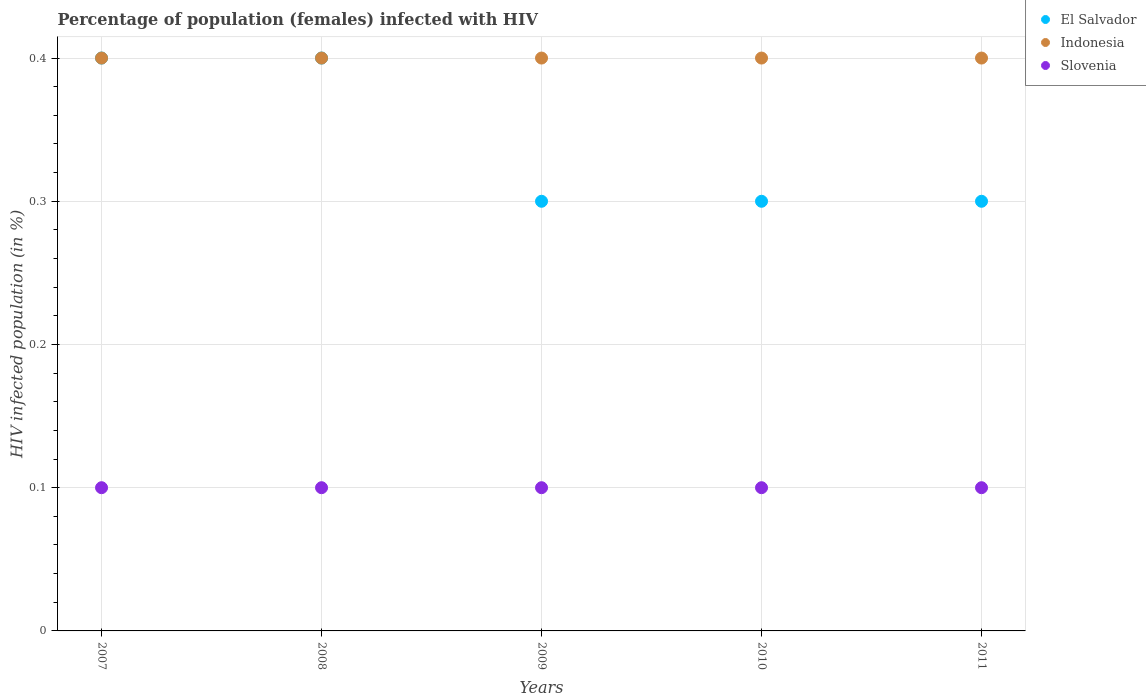What is the percentage of HIV infected female population in El Salvador in 2007?
Keep it short and to the point. 0.4. In which year was the percentage of HIV infected female population in Slovenia maximum?
Your response must be concise. 2007. In which year was the percentage of HIV infected female population in El Salvador minimum?
Your answer should be compact. 2009. What is the difference between the percentage of HIV infected female population in El Salvador in 2007 and that in 2009?
Your answer should be very brief. 0.1. What is the average percentage of HIV infected female population in Indonesia per year?
Provide a succinct answer. 0.4. In the year 2010, what is the difference between the percentage of HIV infected female population in El Salvador and percentage of HIV infected female population in Slovenia?
Provide a succinct answer. 0.2. In how many years, is the percentage of HIV infected female population in Indonesia greater than 0.26 %?
Your answer should be very brief. 5. What is the ratio of the percentage of HIV infected female population in Indonesia in 2009 to that in 2010?
Ensure brevity in your answer.  1. Is the difference between the percentage of HIV infected female population in El Salvador in 2008 and 2010 greater than the difference between the percentage of HIV infected female population in Slovenia in 2008 and 2010?
Provide a succinct answer. Yes. What is the difference between the highest and the second highest percentage of HIV infected female population in El Salvador?
Your answer should be very brief. 0. What is the difference between the highest and the lowest percentage of HIV infected female population in Indonesia?
Provide a short and direct response. 0. Does the percentage of HIV infected female population in Slovenia monotonically increase over the years?
Ensure brevity in your answer.  No. Is the percentage of HIV infected female population in Indonesia strictly less than the percentage of HIV infected female population in Slovenia over the years?
Offer a terse response. No. How many years are there in the graph?
Make the answer very short. 5. What is the difference between two consecutive major ticks on the Y-axis?
Provide a short and direct response. 0.1. Does the graph contain grids?
Your answer should be compact. Yes. Where does the legend appear in the graph?
Offer a very short reply. Top right. How many legend labels are there?
Your response must be concise. 3. What is the title of the graph?
Keep it short and to the point. Percentage of population (females) infected with HIV. Does "Sub-Saharan Africa (all income levels)" appear as one of the legend labels in the graph?
Offer a terse response. No. What is the label or title of the Y-axis?
Provide a short and direct response. HIV infected population (in %). What is the HIV infected population (in %) of Indonesia in 2007?
Provide a short and direct response. 0.4. What is the HIV infected population (in %) of Indonesia in 2008?
Offer a very short reply. 0.4. What is the HIV infected population (in %) of Slovenia in 2008?
Provide a short and direct response. 0.1. What is the HIV infected population (in %) in Indonesia in 2009?
Your answer should be compact. 0.4. What is the HIV infected population (in %) of Slovenia in 2009?
Give a very brief answer. 0.1. What is the HIV infected population (in %) in Slovenia in 2011?
Offer a terse response. 0.1. Across all years, what is the maximum HIV infected population (in %) of Indonesia?
Ensure brevity in your answer.  0.4. Across all years, what is the maximum HIV infected population (in %) in Slovenia?
Offer a terse response. 0.1. Across all years, what is the minimum HIV infected population (in %) in El Salvador?
Offer a terse response. 0.3. What is the total HIV infected population (in %) of Indonesia in the graph?
Your response must be concise. 2. What is the total HIV infected population (in %) of Slovenia in the graph?
Give a very brief answer. 0.5. What is the difference between the HIV infected population (in %) in Slovenia in 2007 and that in 2008?
Your answer should be very brief. 0. What is the difference between the HIV infected population (in %) in Slovenia in 2007 and that in 2009?
Make the answer very short. 0. What is the difference between the HIV infected population (in %) in El Salvador in 2007 and that in 2010?
Keep it short and to the point. 0.1. What is the difference between the HIV infected population (in %) in Indonesia in 2007 and that in 2010?
Your answer should be compact. 0. What is the difference between the HIV infected population (in %) of El Salvador in 2007 and that in 2011?
Your answer should be very brief. 0.1. What is the difference between the HIV infected population (in %) in El Salvador in 2008 and that in 2009?
Make the answer very short. 0.1. What is the difference between the HIV infected population (in %) of Indonesia in 2008 and that in 2009?
Keep it short and to the point. 0. What is the difference between the HIV infected population (in %) in El Salvador in 2008 and that in 2010?
Keep it short and to the point. 0.1. What is the difference between the HIV infected population (in %) in Indonesia in 2008 and that in 2011?
Your answer should be compact. 0. What is the difference between the HIV infected population (in %) in Slovenia in 2008 and that in 2011?
Offer a terse response. 0. What is the difference between the HIV infected population (in %) in El Salvador in 2009 and that in 2010?
Ensure brevity in your answer.  0. What is the difference between the HIV infected population (in %) in Slovenia in 2009 and that in 2010?
Provide a succinct answer. 0. What is the difference between the HIV infected population (in %) of Slovenia in 2010 and that in 2011?
Your answer should be compact. 0. What is the difference between the HIV infected population (in %) in El Salvador in 2007 and the HIV infected population (in %) in Indonesia in 2008?
Your response must be concise. 0. What is the difference between the HIV infected population (in %) in Indonesia in 2007 and the HIV infected population (in %) in Slovenia in 2008?
Provide a short and direct response. 0.3. What is the difference between the HIV infected population (in %) of Indonesia in 2007 and the HIV infected population (in %) of Slovenia in 2009?
Offer a terse response. 0.3. What is the difference between the HIV infected population (in %) in El Salvador in 2007 and the HIV infected population (in %) in Slovenia in 2011?
Your response must be concise. 0.3. What is the difference between the HIV infected population (in %) of Indonesia in 2007 and the HIV infected population (in %) of Slovenia in 2011?
Your answer should be compact. 0.3. What is the difference between the HIV infected population (in %) in El Salvador in 2008 and the HIV infected population (in %) in Slovenia in 2009?
Your response must be concise. 0.3. What is the difference between the HIV infected population (in %) in El Salvador in 2008 and the HIV infected population (in %) in Indonesia in 2010?
Your response must be concise. 0. What is the difference between the HIV infected population (in %) of El Salvador in 2008 and the HIV infected population (in %) of Slovenia in 2010?
Make the answer very short. 0.3. What is the difference between the HIV infected population (in %) of El Salvador in 2008 and the HIV infected population (in %) of Slovenia in 2011?
Make the answer very short. 0.3. What is the difference between the HIV infected population (in %) of Indonesia in 2008 and the HIV infected population (in %) of Slovenia in 2011?
Ensure brevity in your answer.  0.3. What is the difference between the HIV infected population (in %) in Indonesia in 2009 and the HIV infected population (in %) in Slovenia in 2010?
Your answer should be very brief. 0.3. What is the difference between the HIV infected population (in %) in El Salvador in 2009 and the HIV infected population (in %) in Indonesia in 2011?
Keep it short and to the point. -0.1. What is the difference between the HIV infected population (in %) in El Salvador in 2009 and the HIV infected population (in %) in Slovenia in 2011?
Provide a succinct answer. 0.2. What is the difference between the HIV infected population (in %) of Indonesia in 2009 and the HIV infected population (in %) of Slovenia in 2011?
Your answer should be very brief. 0.3. What is the difference between the HIV infected population (in %) in El Salvador in 2010 and the HIV infected population (in %) in Indonesia in 2011?
Make the answer very short. -0.1. What is the difference between the HIV infected population (in %) of Indonesia in 2010 and the HIV infected population (in %) of Slovenia in 2011?
Offer a very short reply. 0.3. What is the average HIV infected population (in %) in El Salvador per year?
Provide a succinct answer. 0.34. What is the average HIV infected population (in %) of Indonesia per year?
Your response must be concise. 0.4. In the year 2008, what is the difference between the HIV infected population (in %) in El Salvador and HIV infected population (in %) in Indonesia?
Offer a terse response. 0. In the year 2008, what is the difference between the HIV infected population (in %) in El Salvador and HIV infected population (in %) in Slovenia?
Make the answer very short. 0.3. In the year 2008, what is the difference between the HIV infected population (in %) in Indonesia and HIV infected population (in %) in Slovenia?
Give a very brief answer. 0.3. In the year 2009, what is the difference between the HIV infected population (in %) of El Salvador and HIV infected population (in %) of Indonesia?
Provide a short and direct response. -0.1. In the year 2009, what is the difference between the HIV infected population (in %) in El Salvador and HIV infected population (in %) in Slovenia?
Keep it short and to the point. 0.2. In the year 2009, what is the difference between the HIV infected population (in %) of Indonesia and HIV infected population (in %) of Slovenia?
Provide a succinct answer. 0.3. In the year 2011, what is the difference between the HIV infected population (in %) in El Salvador and HIV infected population (in %) in Slovenia?
Give a very brief answer. 0.2. What is the ratio of the HIV infected population (in %) of El Salvador in 2007 to that in 2008?
Your response must be concise. 1. What is the ratio of the HIV infected population (in %) in El Salvador in 2007 to that in 2009?
Provide a short and direct response. 1.33. What is the ratio of the HIV infected population (in %) in Indonesia in 2007 to that in 2009?
Offer a very short reply. 1. What is the ratio of the HIV infected population (in %) of Slovenia in 2007 to that in 2009?
Offer a terse response. 1. What is the ratio of the HIV infected population (in %) in El Salvador in 2007 to that in 2010?
Your response must be concise. 1.33. What is the ratio of the HIV infected population (in %) in Indonesia in 2007 to that in 2010?
Keep it short and to the point. 1. What is the ratio of the HIV infected population (in %) in Slovenia in 2007 to that in 2010?
Make the answer very short. 1. What is the ratio of the HIV infected population (in %) in El Salvador in 2008 to that in 2010?
Your answer should be very brief. 1.33. What is the ratio of the HIV infected population (in %) of Indonesia in 2008 to that in 2010?
Provide a succinct answer. 1. What is the ratio of the HIV infected population (in %) of Slovenia in 2008 to that in 2010?
Keep it short and to the point. 1. What is the ratio of the HIV infected population (in %) of El Salvador in 2008 to that in 2011?
Give a very brief answer. 1.33. What is the ratio of the HIV infected population (in %) in Slovenia in 2008 to that in 2011?
Your answer should be compact. 1. What is the ratio of the HIV infected population (in %) in El Salvador in 2009 to that in 2010?
Offer a terse response. 1. What is the ratio of the HIV infected population (in %) in Slovenia in 2009 to that in 2011?
Your answer should be compact. 1. What is the ratio of the HIV infected population (in %) in Indonesia in 2010 to that in 2011?
Give a very brief answer. 1. What is the difference between the highest and the second highest HIV infected population (in %) in El Salvador?
Offer a terse response. 0. What is the difference between the highest and the second highest HIV infected population (in %) of Slovenia?
Ensure brevity in your answer.  0. What is the difference between the highest and the lowest HIV infected population (in %) in El Salvador?
Make the answer very short. 0.1. What is the difference between the highest and the lowest HIV infected population (in %) in Indonesia?
Keep it short and to the point. 0. What is the difference between the highest and the lowest HIV infected population (in %) in Slovenia?
Your answer should be compact. 0. 